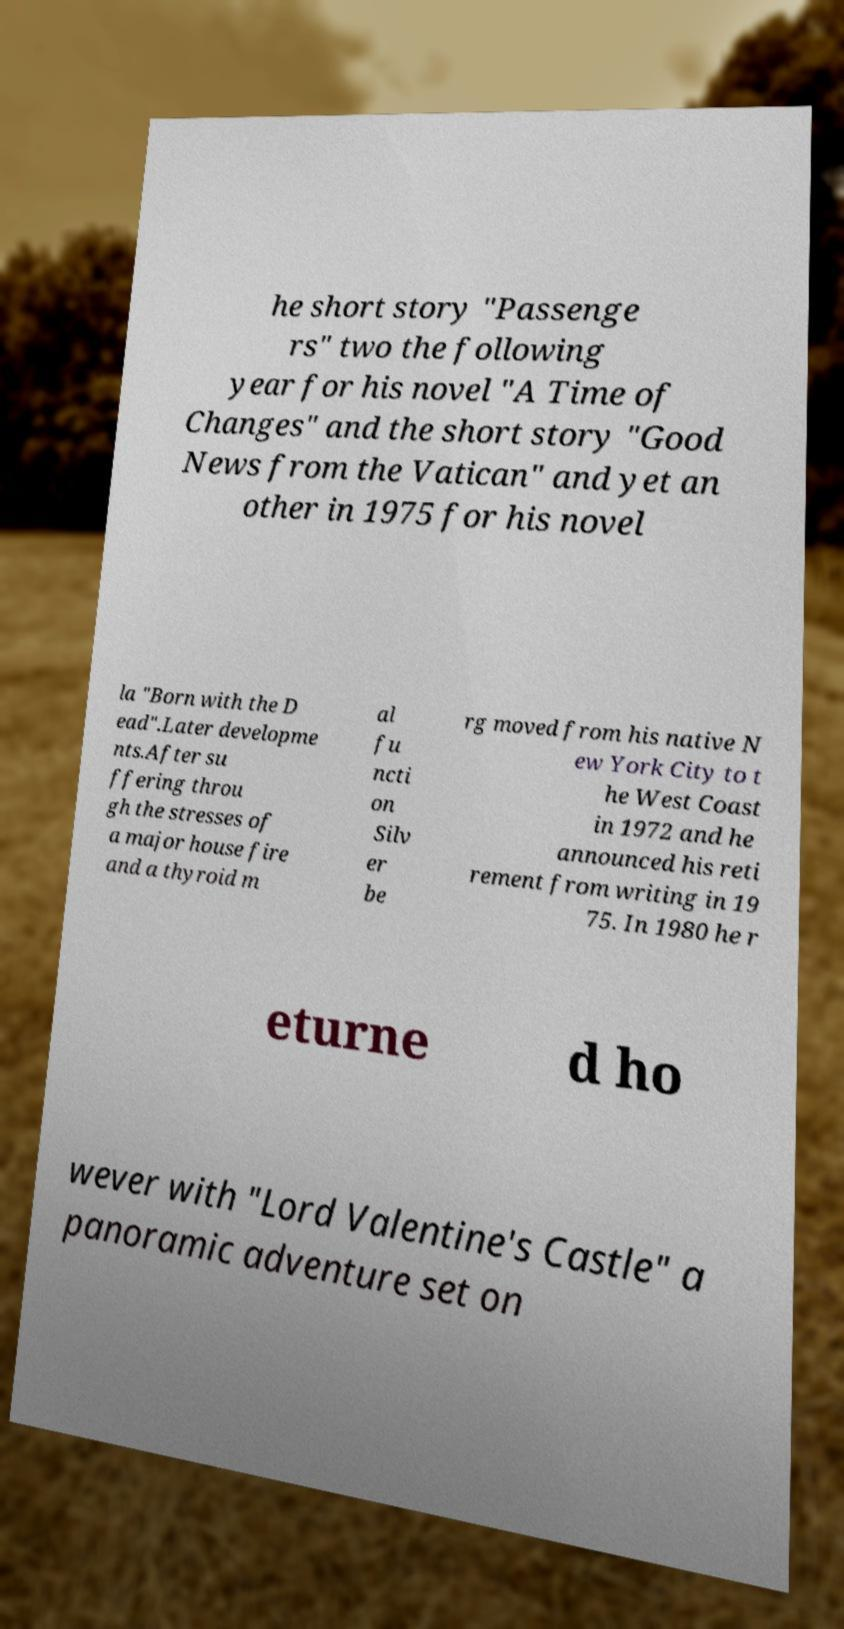I need the written content from this picture converted into text. Can you do that? he short story "Passenge rs" two the following year for his novel "A Time of Changes" and the short story "Good News from the Vatican" and yet an other in 1975 for his novel la "Born with the D ead".Later developme nts.After su ffering throu gh the stresses of a major house fire and a thyroid m al fu ncti on Silv er be rg moved from his native N ew York City to t he West Coast in 1972 and he announced his reti rement from writing in 19 75. In 1980 he r eturne d ho wever with "Lord Valentine's Castle" a panoramic adventure set on 